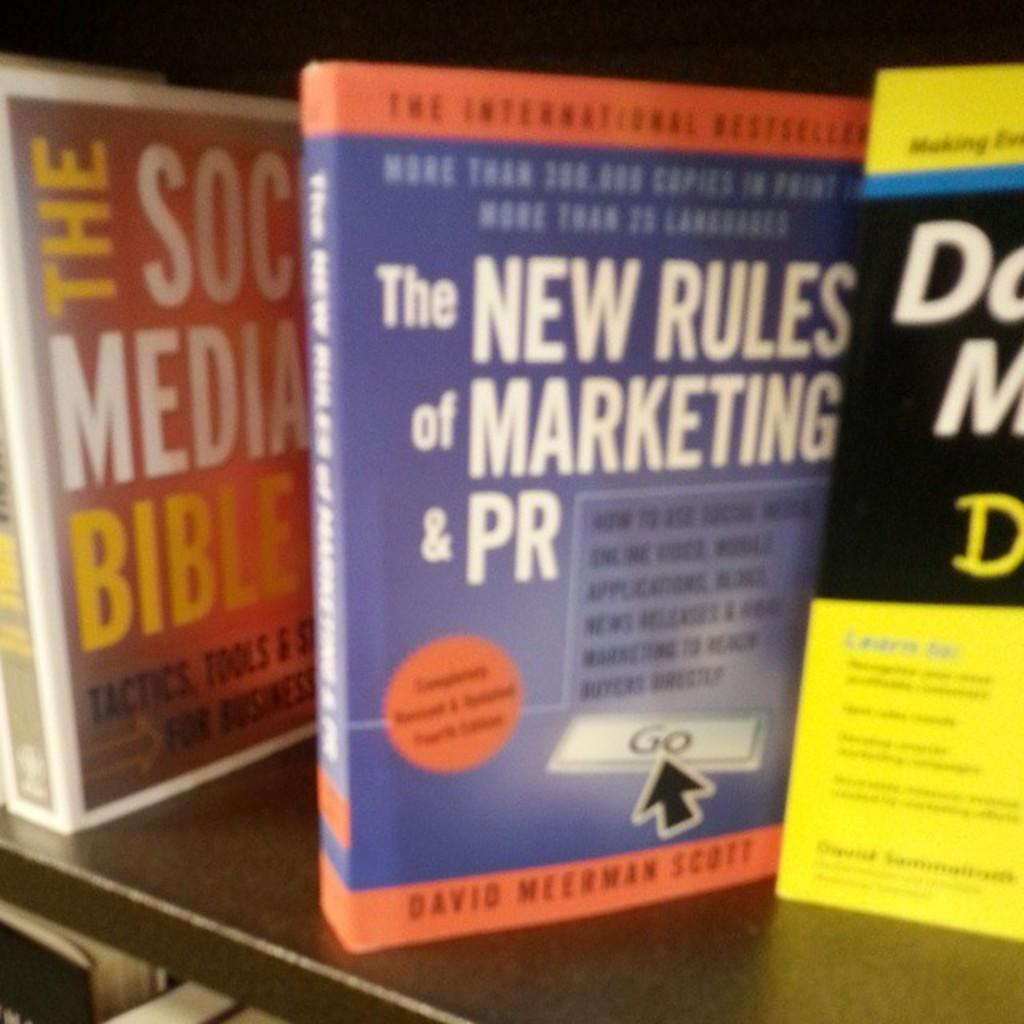<image>
Summarize the visual content of the image. a book that is about the new rules of marketing and pr 